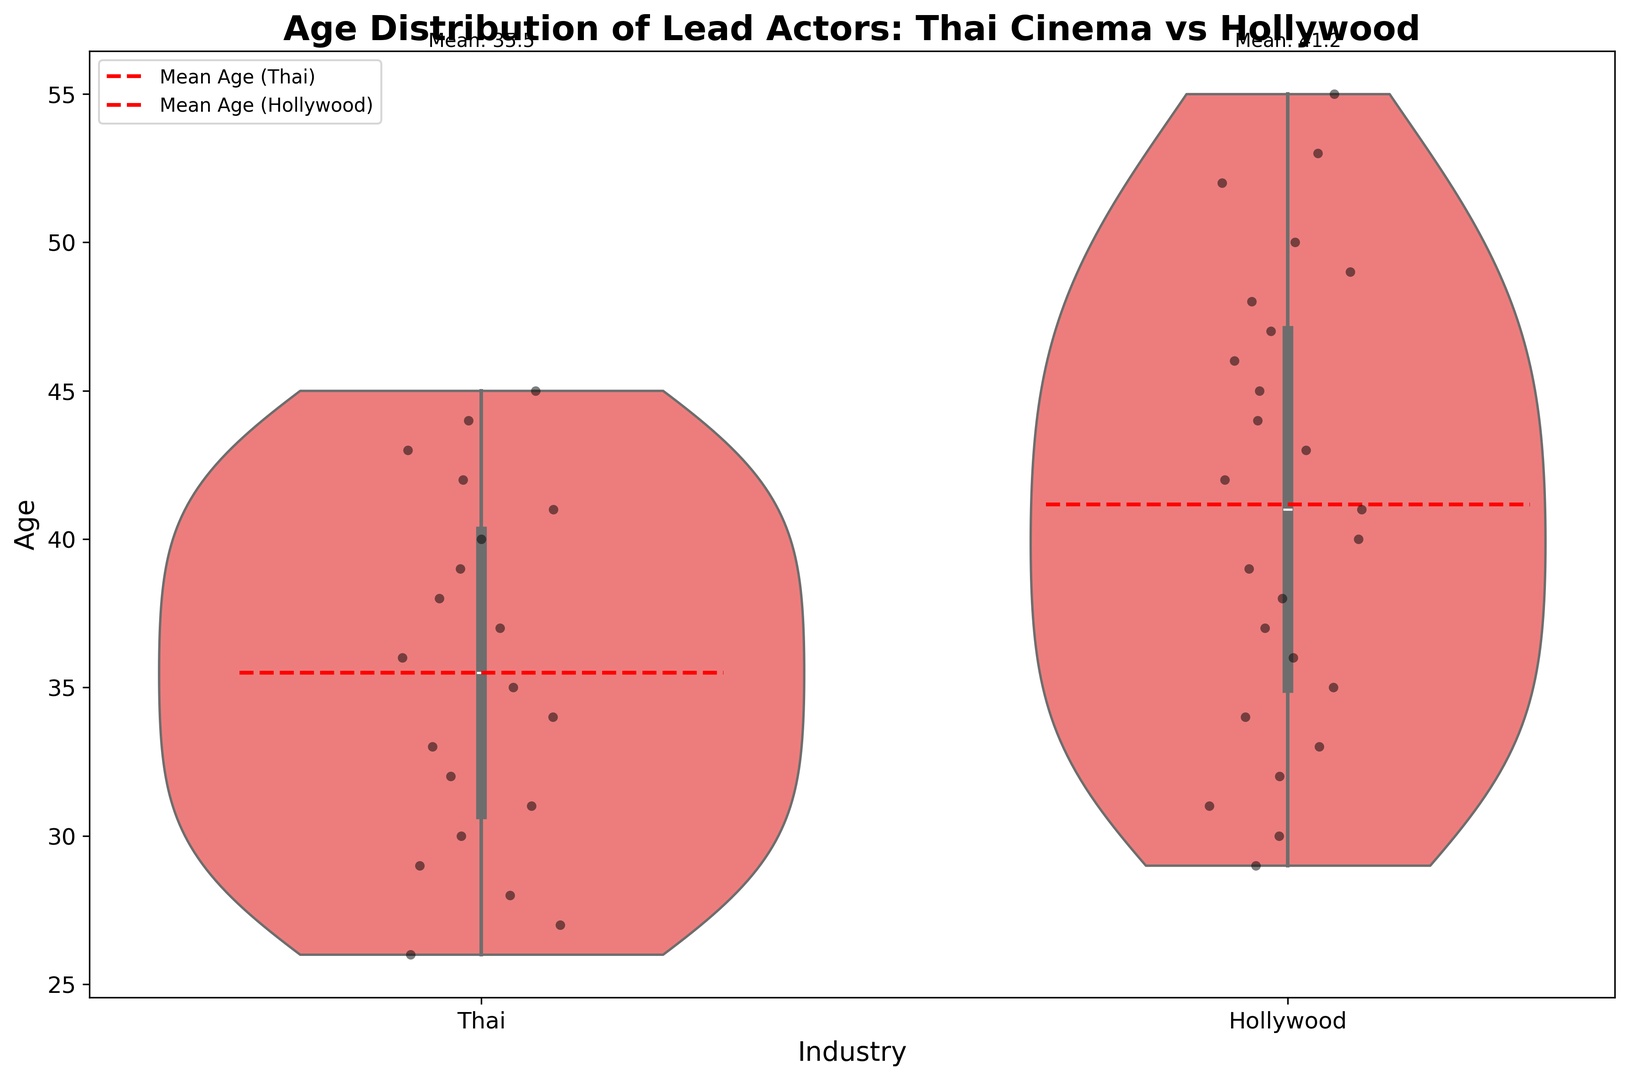What is the median age of lead actors in Thai cinema? To find the median age, look at the center of the distribution for Thai cinema in the violin plot. For symmetric distributions, the median will fall around the middle point.
Answer: 34.5 What is the mean age of lead actors in Hollywood? The mean age for each industry is indicated by a dashed red line and labeled with its value at the top of the plot. For Hollywood, this value is 41.4 years.
Answer: 41.4 Which industry has a greater range in ages of lead actors? The range of ages can be seen by looking at the length of the violin plots. The plot for Hollywood shows a wider spread compared to Thai cinema, indicating a greater range.
Answer: Hollywood Which industry's lead actors have the higher mean age? Compare the mean ages labeled on the plot. Hollywood has a mean age of 41.4 years, while Thai cinema has a mean age of 35.1 years.
Answer: Hollywood Are there any outliers in the age distribution of lead actors in either industry? An outlier would be visually noticeable as a point far outside the main distribution of the violin plots or jittered points. Neither industry shows prominent outliers in this plot.
Answer: No What's the median age of lead actors in Hollywood? To find the median age, look at the center of the distribution for Hollywood in the violin plot. Typically, this will be around where the plot is the widest.
Answer: 42 Is the age distribution more spread out in Thai cinema or Hollywood? A more spread-out distribution will have a wider violin plot. Hollywood's distribution covers a broader age range, indicating it is more spread out.
Answer: Hollywood How do the age distributions of the two industries compare visually? Visually, Hollywood has a wider age distribution compared to the more compact distribution of Thai cinema, showing that the ages of lead actors in Hollywood vary more than those in Thai cinema.
Answer: Hollywood has a wider distribution 